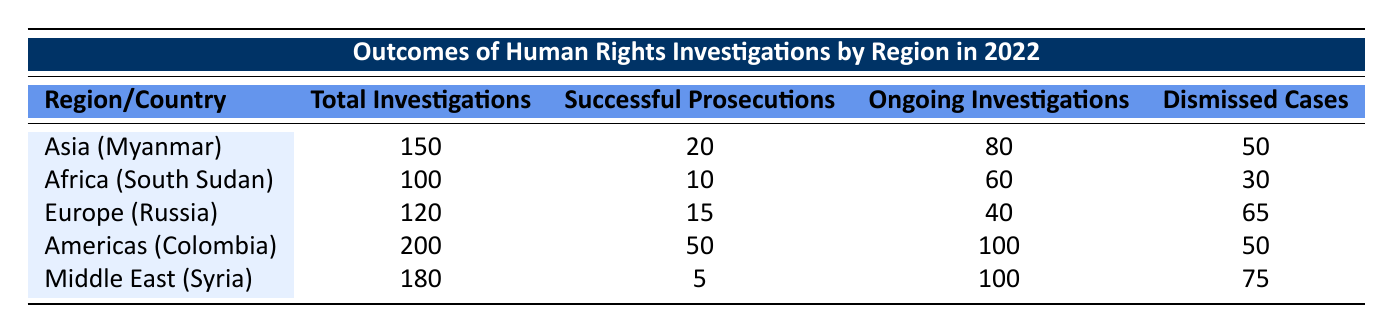What is the total number of investigations conducted in Asia? In the table, the region of Asia corresponds to Myanmar, which has a total of 150 investigations listed.
Answer: 150 How many successful prosecutions were recorded in Africa? The table shows that in Africa, specifically in South Sudan, there were 10 successful prosecutions.
Answer: 10 Which region had the highest number of ongoing investigations? By examining the table, the region of the Americas (Colombia) shows the highest number of ongoing investigations with a total of 100.
Answer: Americas Is it true that there were more dismissed cases in the Middle East than in Europe? Looking at the table, the Middle East (Syria) has 75 dismissed cases, while Europe (Russia) has 65. Therefore, it is true that the Middle East had more dismissed cases.
Answer: Yes What is the total number of investigations across all regions listed in the table? To find the total, we add up all the investigations: 150 (Asia) + 100 (Africa) + 120 (Europe) + 200 (Americas) + 180 (Middle East) = 850.
Answer: 850 What is the average number of successful prosecutions for the regions listed? The successful prosecutions are: 20 (Asia) + 10 (Africa) + 15 (Europe) + 50 (Americas) + 5 (Middle East) = 100. There are 5 regions, so the average is 100/5 = 20.
Answer: 20 How many more ongoing investigations are there in Syria compared to Russia? Syria has 100 ongoing investigations while Russia has 40. To find the difference, we subtract: 100 - 40 = 60.
Answer: 60 Is it true that Colombia had the highest number of successful prosecutions? The table indicates that Colombia had 50 successful prosecutions, which is higher than any other region listed, confirming that it is true.
Answer: Yes Which region had the lowest number of successful prosecutions? Reviewing the table, Syria in the Middle East had the lowest number with only 5 successful prosecutions.
Answer: Middle East 